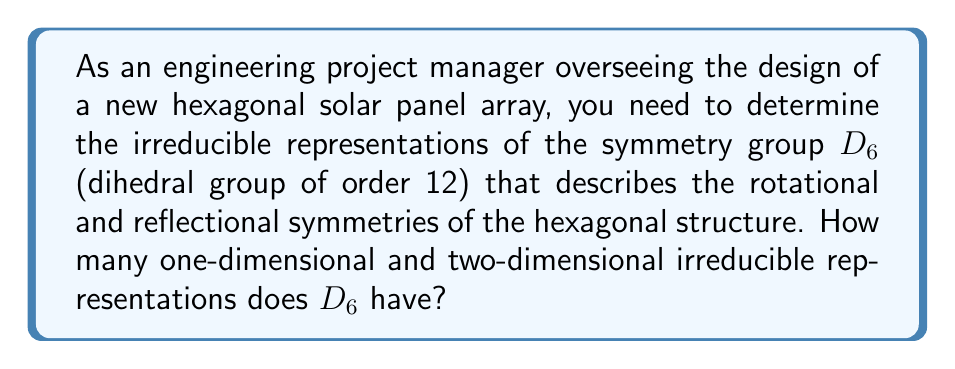Solve this math problem. To determine the irreducible representations of the dihedral group $D_6$, we'll follow these steps:

1. Recall the structure of $D_6$:
   - It has 12 elements: 6 rotations and 6 reflections
   - The order of the group is $|D_6| = 12$

2. Use the class equation:
   $$|G| = \sum_{i} |C_i|$$
   where $|C_i|$ is the size of each conjugacy class.

3. Identify the conjugacy classes of $D_6$:
   - $C_1 = \{e\}$ (identity)
   - $C_2 = \{r^3\}$ (180° rotation)
   - $C_3 = \{r, r^5\}$ (60° and 300° rotations)
   - $C_4 = \{r^2, r^4\}$ (120° and 240° rotations)
   - $C_5 = \{s, sr^2, sr^4\}$ (reflections through diagonals)
   - $C_6 = \{sr, sr^3, sr^5\}$ (reflections through vertices)

4. Count the number of conjugacy classes: 6

5. Apply the formula for the number of irreducible representations:
   - The number of irreducible representations equals the number of conjugacy classes
   - Therefore, $D_6$ has 6 irreducible representations

6. Use the sum of squares formula:
   $$|G| = \sum_{i} d_i^2$$
   where $d_i$ is the dimension of each irreducible representation

7. Determine the dimensions:
   - We know $D_6$ has 4 one-dimensional representations (corresponding to the four 1×1 matrices that square to the identity matrix)
   - The remaining two must be two-dimensional to satisfy the sum of squares formula:
     $$12 = 1^2 + 1^2 + 1^2 + 1^2 + 2^2 + 2^2$$

Therefore, $D_6$ has 4 one-dimensional and 2 two-dimensional irreducible representations.
Answer: 4 one-dimensional and 2 two-dimensional irreducible representations 